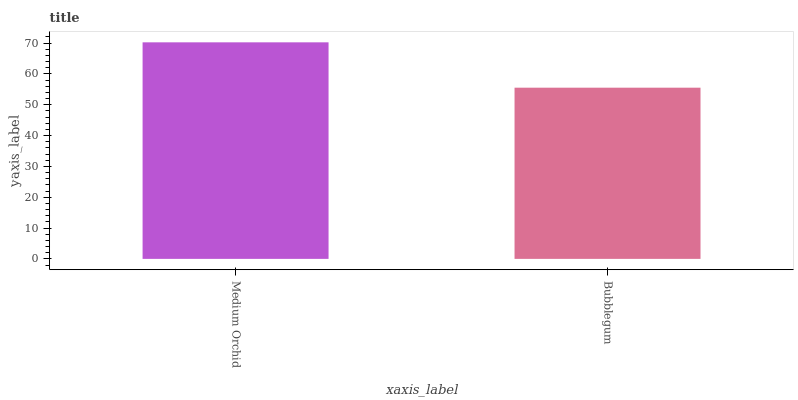Is Bubblegum the maximum?
Answer yes or no. No. Is Medium Orchid greater than Bubblegum?
Answer yes or no. Yes. Is Bubblegum less than Medium Orchid?
Answer yes or no. Yes. Is Bubblegum greater than Medium Orchid?
Answer yes or no. No. Is Medium Orchid less than Bubblegum?
Answer yes or no. No. Is Medium Orchid the high median?
Answer yes or no. Yes. Is Bubblegum the low median?
Answer yes or no. Yes. Is Bubblegum the high median?
Answer yes or no. No. Is Medium Orchid the low median?
Answer yes or no. No. 